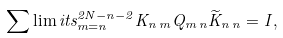Convert formula to latex. <formula><loc_0><loc_0><loc_500><loc_500>\sum \lim i t s _ { m = n } ^ { 2 N - n - 2 } { K } _ { n \, m } { Q } _ { m \, n } \widetilde { K } _ { n \, n } = { I } ,</formula> 